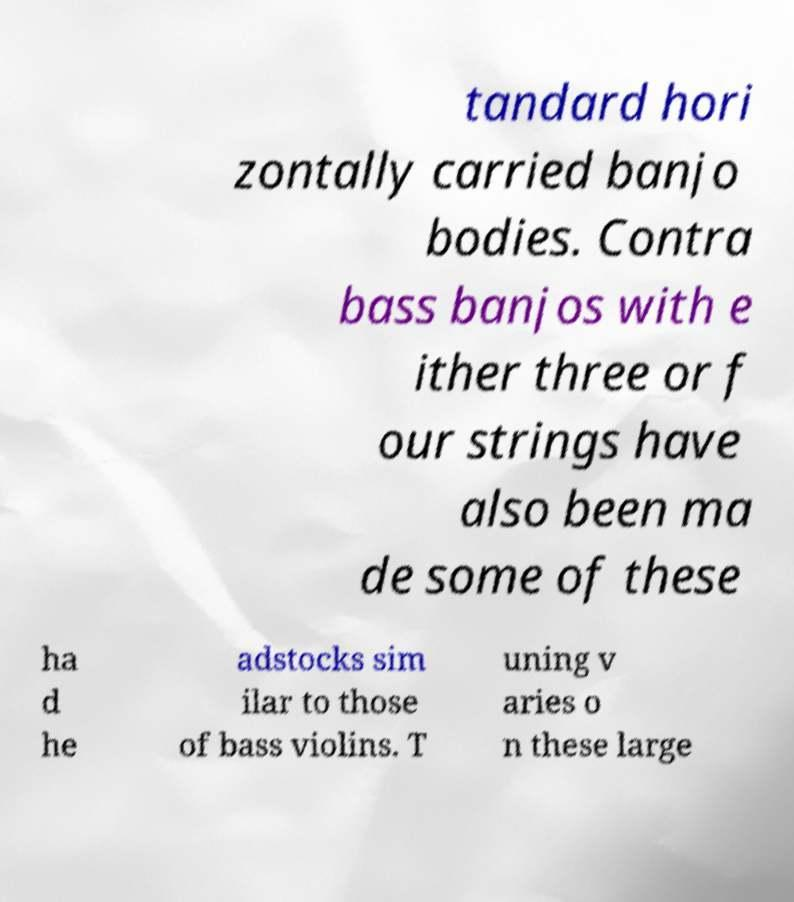Could you extract and type out the text from this image? tandard hori zontally carried banjo bodies. Contra bass banjos with e ither three or f our strings have also been ma de some of these ha d he adstocks sim ilar to those of bass violins. T uning v aries o n these large 